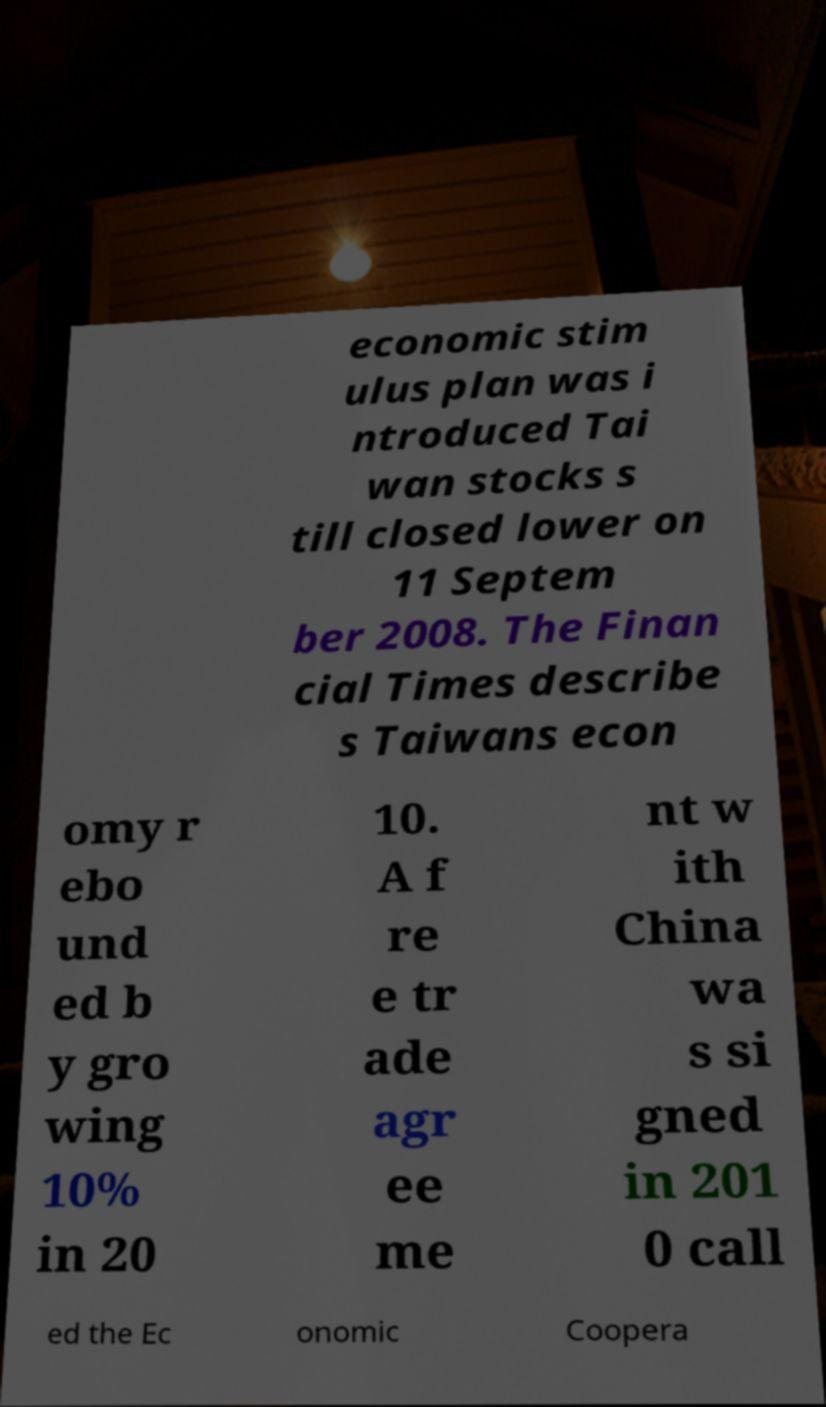Could you assist in decoding the text presented in this image and type it out clearly? economic stim ulus plan was i ntroduced Tai wan stocks s till closed lower on 11 Septem ber 2008. The Finan cial Times describe s Taiwans econ omy r ebo und ed b y gro wing 10% in 20 10. A f re e tr ade agr ee me nt w ith China wa s si gned in 201 0 call ed the Ec onomic Coopera 